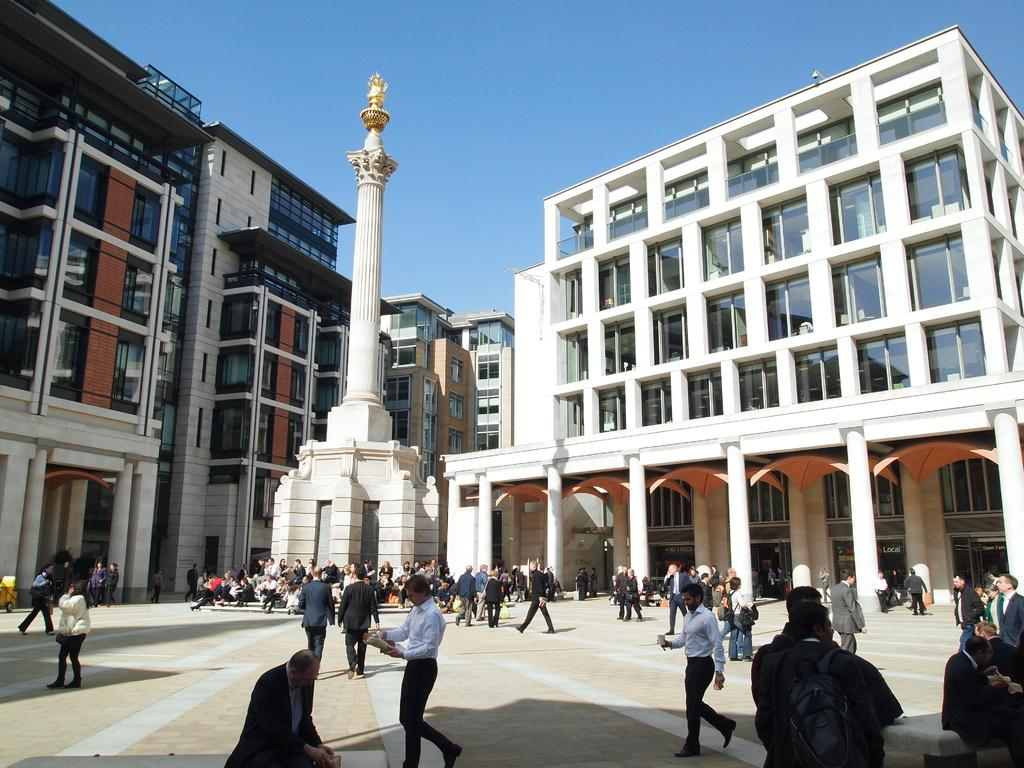How many people are in the image? There is a group of people in the image. What are the people in the image doing? Some people are seated, some are standing, and some are walking. What can be seen in the background of the image? There are buildings and a tower in the background of the image. Can you see any cobwebs in the image? There is no mention of cobwebs in the provided facts, so we cannot determine if any are present in the image. Are the people in the image interacting with a friend? The provided facts do not mention any friends or interactions with friends, so we cannot determine if any are present in the image. 